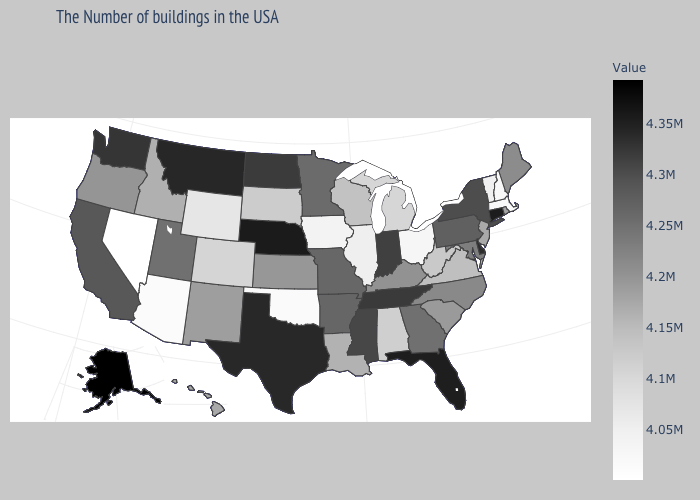Among the states that border Nevada , which have the lowest value?
Keep it brief. Arizona. Does Idaho have a lower value than Connecticut?
Concise answer only. Yes. Among the states that border Wyoming , which have the lowest value?
Quick response, please. Colorado. Does the map have missing data?
Be succinct. No. Which states hav the highest value in the MidWest?
Concise answer only. Nebraska. Does Nevada have the lowest value in the USA?
Quick response, please. Yes. Among the states that border California , does Oregon have the highest value?
Quick response, please. Yes. 